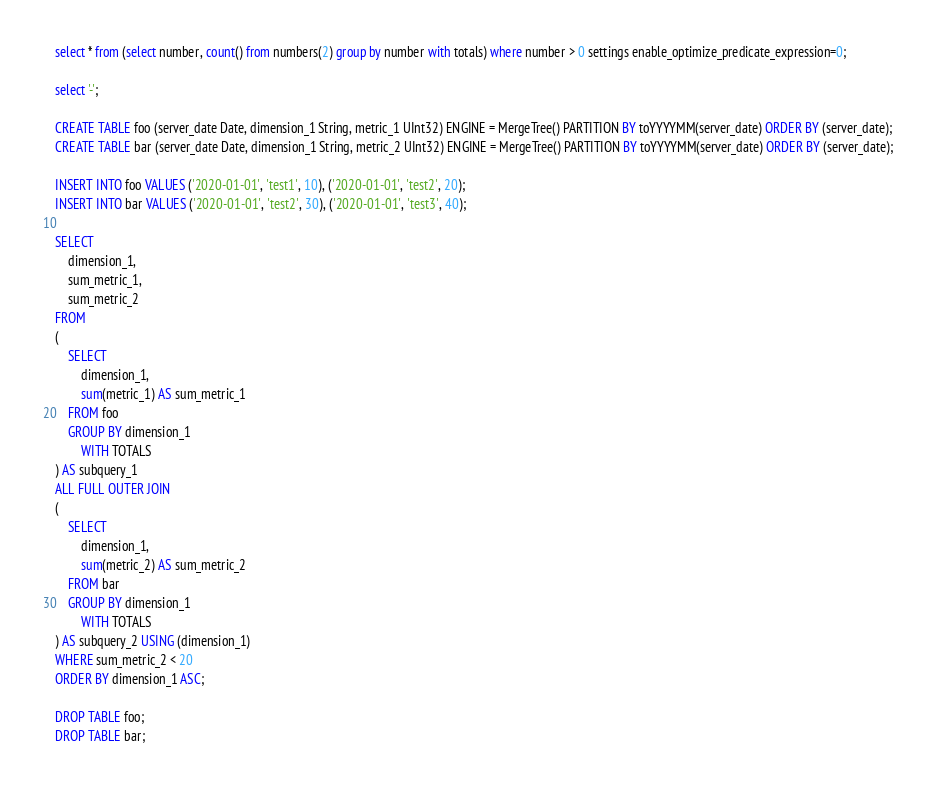Convert code to text. <code><loc_0><loc_0><loc_500><loc_500><_SQL_>select * from (select number, count() from numbers(2) group by number with totals) where number > 0 settings enable_optimize_predicate_expression=0;

select '-';

CREATE TABLE foo (server_date Date, dimension_1 String, metric_1 UInt32) ENGINE = MergeTree() PARTITION BY toYYYYMM(server_date) ORDER BY (server_date);
CREATE TABLE bar (server_date Date, dimension_1 String, metric_2 UInt32) ENGINE = MergeTree() PARTITION BY toYYYYMM(server_date) ORDER BY (server_date);

INSERT INTO foo VALUES ('2020-01-01', 'test1', 10), ('2020-01-01', 'test2', 20);
INSERT INTO bar VALUES ('2020-01-01', 'test2', 30), ('2020-01-01', 'test3', 40);

SELECT
    dimension_1,
    sum_metric_1,
    sum_metric_2
FROM
(
    SELECT
        dimension_1,
        sum(metric_1) AS sum_metric_1
    FROM foo
    GROUP BY dimension_1
        WITH TOTALS
) AS subquery_1
ALL FULL OUTER JOIN
(
    SELECT
        dimension_1,
        sum(metric_2) AS sum_metric_2
    FROM bar
    GROUP BY dimension_1
        WITH TOTALS
) AS subquery_2 USING (dimension_1)
WHERE sum_metric_2 < 20
ORDER BY dimension_1 ASC;

DROP TABLE foo;
DROP TABLE bar;
</code> 